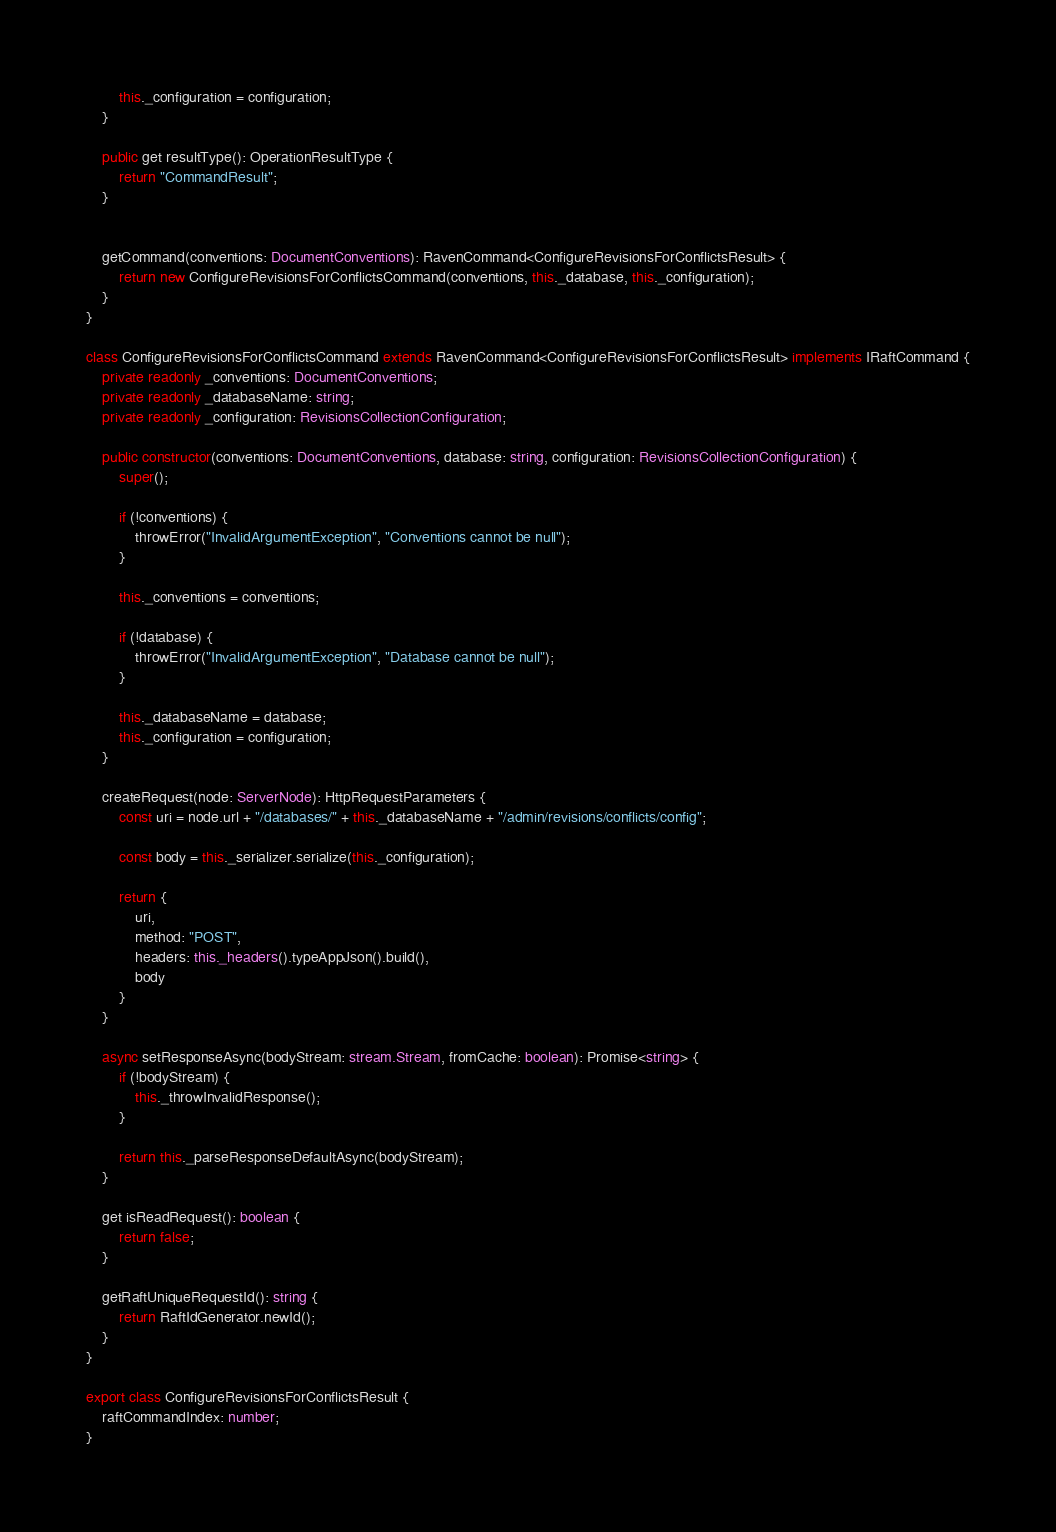<code> <loc_0><loc_0><loc_500><loc_500><_TypeScript_>
        this._configuration = configuration;
    }

    public get resultType(): OperationResultType {
        return "CommandResult";
    }


    getCommand(conventions: DocumentConventions): RavenCommand<ConfigureRevisionsForConflictsResult> {
        return new ConfigureRevisionsForConflictsCommand(conventions, this._database, this._configuration);
    }
}

class ConfigureRevisionsForConflictsCommand extends RavenCommand<ConfigureRevisionsForConflictsResult> implements IRaftCommand {
    private readonly _conventions: DocumentConventions;
    private readonly _databaseName: string;
    private readonly _configuration: RevisionsCollectionConfiguration;

    public constructor(conventions: DocumentConventions, database: string, configuration: RevisionsCollectionConfiguration) {
        super();

        if (!conventions) {
            throwError("InvalidArgumentException", "Conventions cannot be null");
        }

        this._conventions = conventions;

        if (!database) {
            throwError("InvalidArgumentException", "Database cannot be null");
        }

        this._databaseName = database;
        this._configuration = configuration;
    }

    createRequest(node: ServerNode): HttpRequestParameters {
        const uri = node.url + "/databases/" + this._databaseName + "/admin/revisions/conflicts/config";

        const body = this._serializer.serialize(this._configuration);

        return {
            uri,
            method: "POST",
            headers: this._headers().typeAppJson().build(),
            body
        }
    }

    async setResponseAsync(bodyStream: stream.Stream, fromCache: boolean): Promise<string> {
        if (!bodyStream) {
            this._throwInvalidResponse();
        }

        return this._parseResponseDefaultAsync(bodyStream);
    }

    get isReadRequest(): boolean {
        return false;
    }

    getRaftUniqueRequestId(): string {
        return RaftIdGenerator.newId();
    }
}

export class ConfigureRevisionsForConflictsResult {
    raftCommandIndex: number;
}</code> 